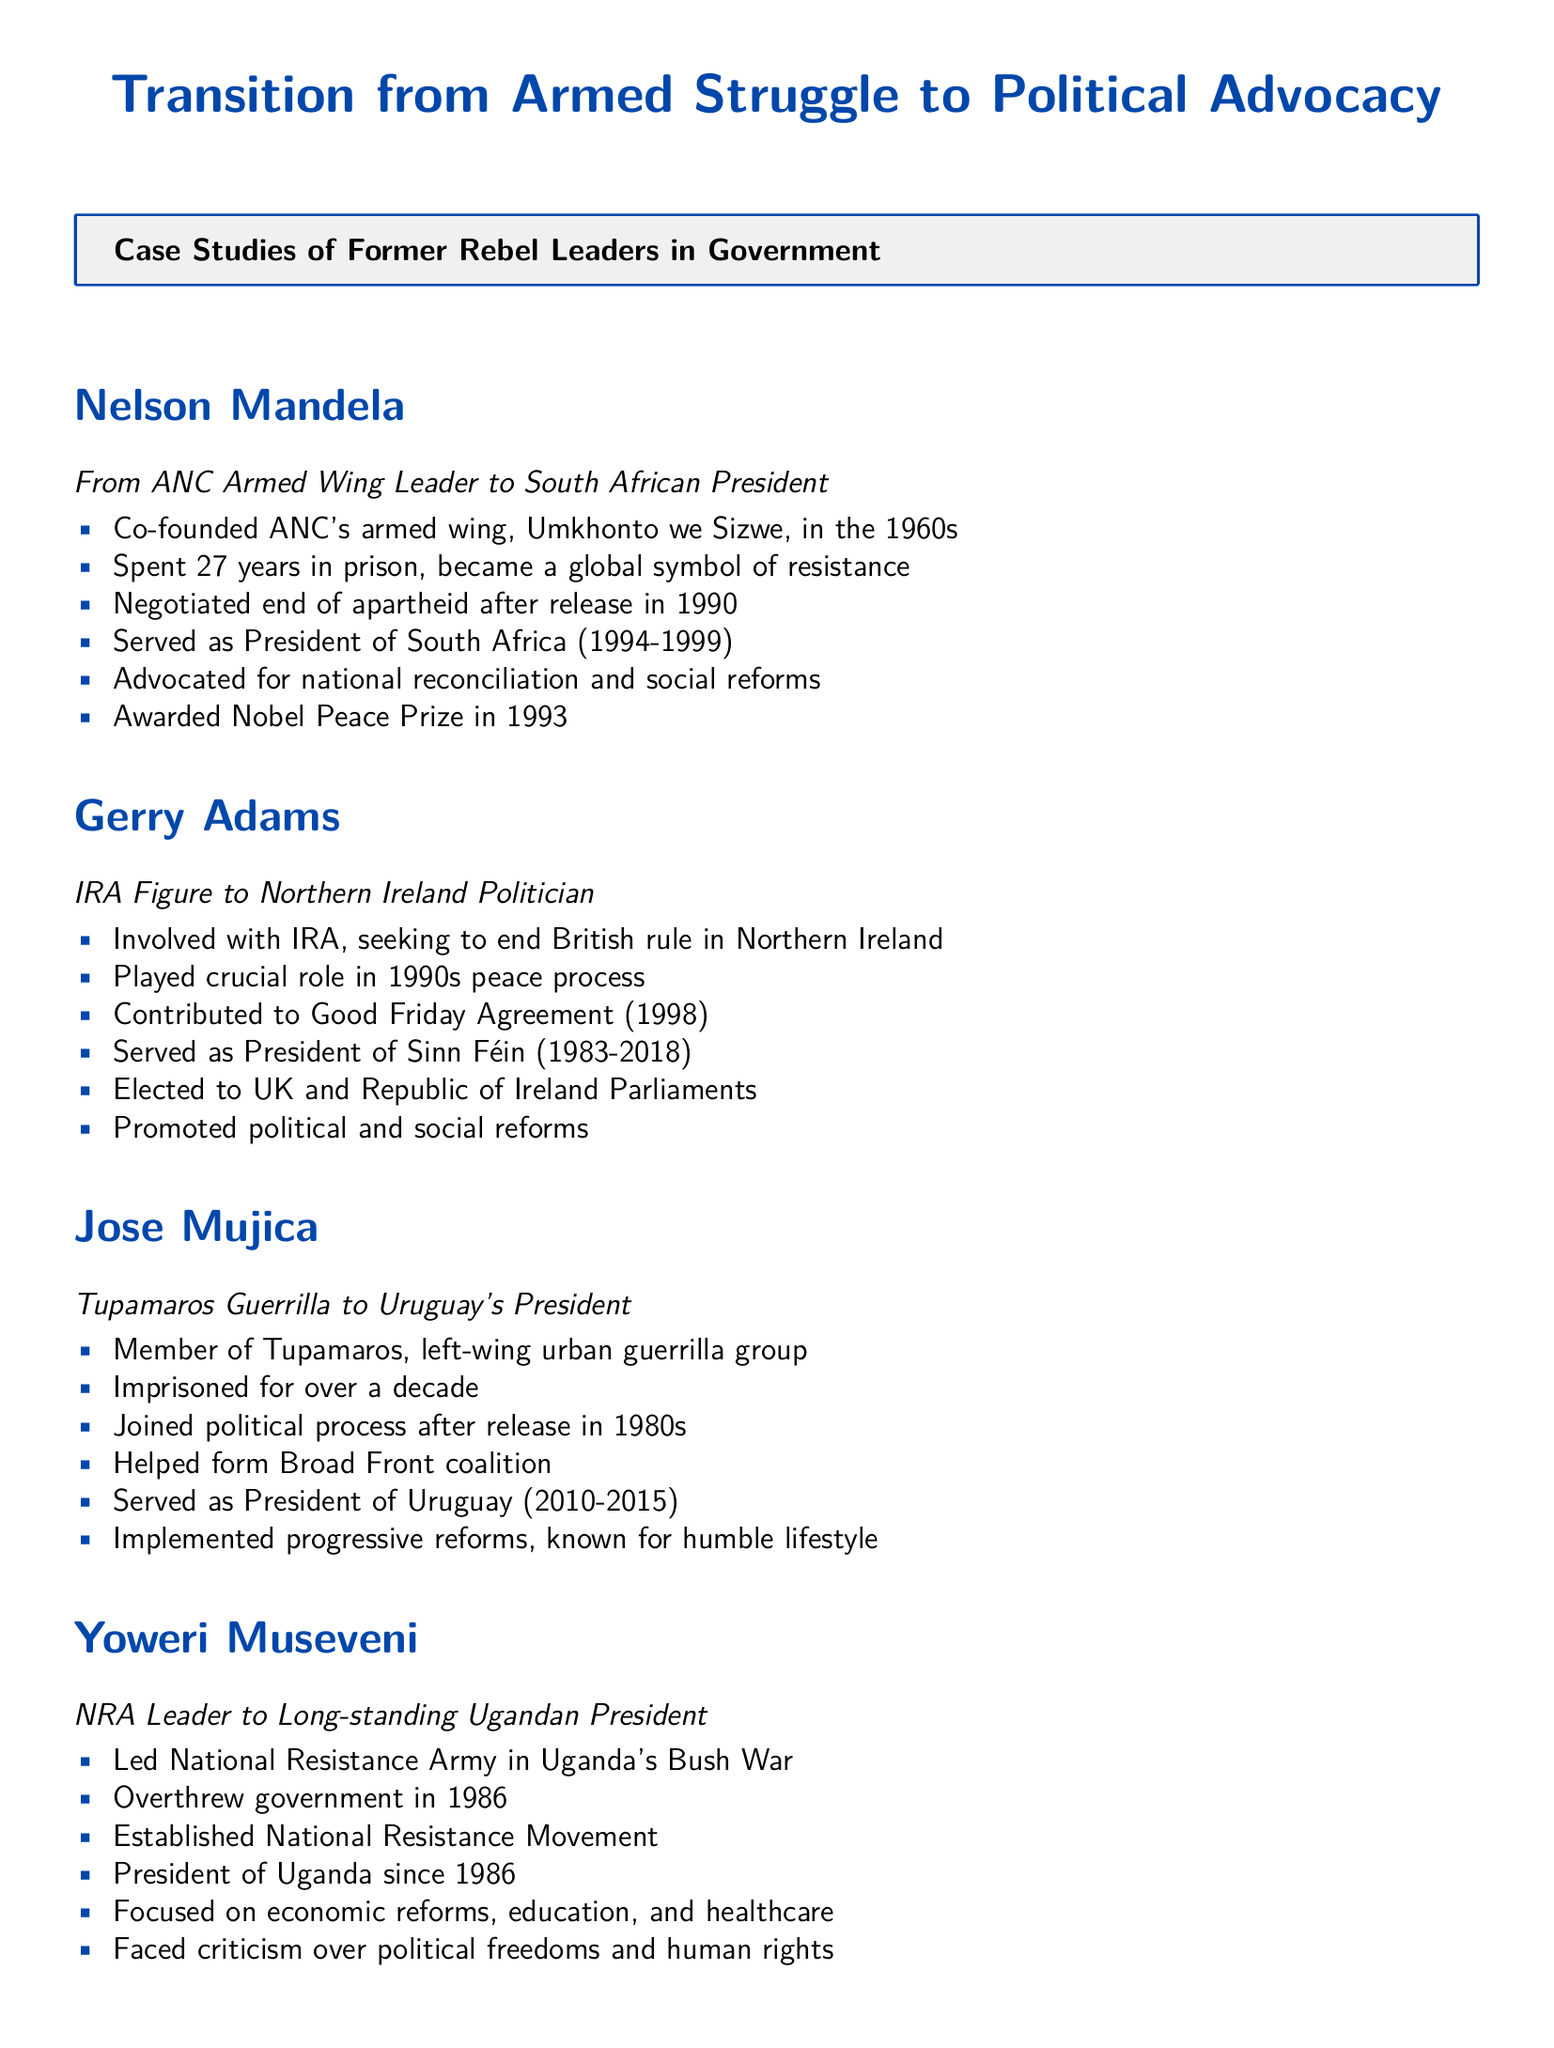What organization did Nelson Mandela co-found? The document states that Nelson Mandela co-founded the ANC's armed wing, Umkhonto we Sizwe, in the 1960s.
Answer: Umkhonto we Sizwe How many years did Nelson Mandela spend in prison? According to the document, Nelson Mandela spent 27 years in prison, becoming a global symbol of resistance.
Answer: 27 years What significant agreement did Gerry Adams contribute to? The document mentions that Gerry Adams played a crucial role in the Good Friday Agreement in 1998.
Answer: Good Friday Agreement When did Jose Mujica serve as President of Uruguay? The document notes that Jose Mujica served as President of Uruguay from 2010 to 2015.
Answer: 2010-2015 Which country has Yoweri Museveni been president of since 1986? The document indicates that Yoweri Museveni has been President of Uganda since 1986.
Answer: Uganda What major focus is highlighted for Yoweri Museveni's presidency? The document emphasizes that Yoweri Museveni focused on economic reforms, education, and healthcare during his presidency.
Answer: Economic reforms What lifestyle is Jose Mujica known for? The document states that Jose Mujica is known for his humble lifestyle.
Answer: Humble lifestyle Which former rebel leader was awarded the Nobel Peace Prize? The document mentions that Nelson Mandela was awarded the Nobel Peace Prize in 1993.
Answer: Nelson Mandela What coalition did Jose Mujica help form? According to the document, Jose Mujica helped form the Broad Front coalition.
Answer: Broad Front coalition 